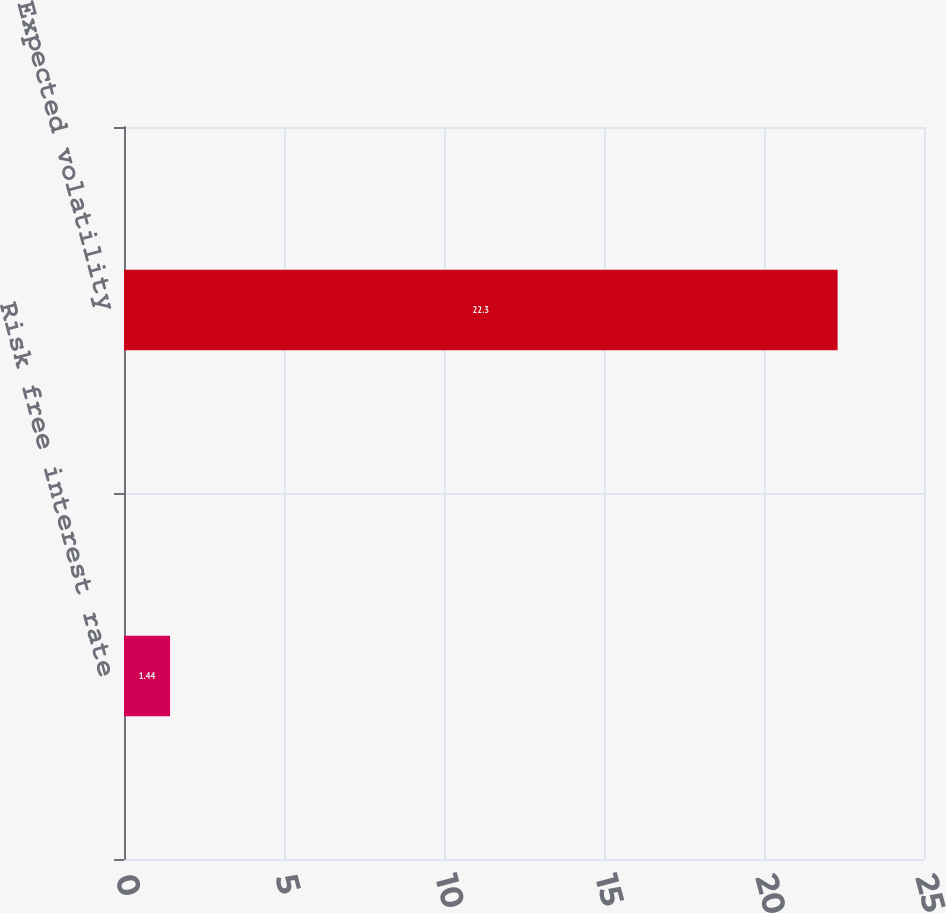<chart> <loc_0><loc_0><loc_500><loc_500><bar_chart><fcel>Risk free interest rate<fcel>Expected volatility<nl><fcel>1.44<fcel>22.3<nl></chart> 